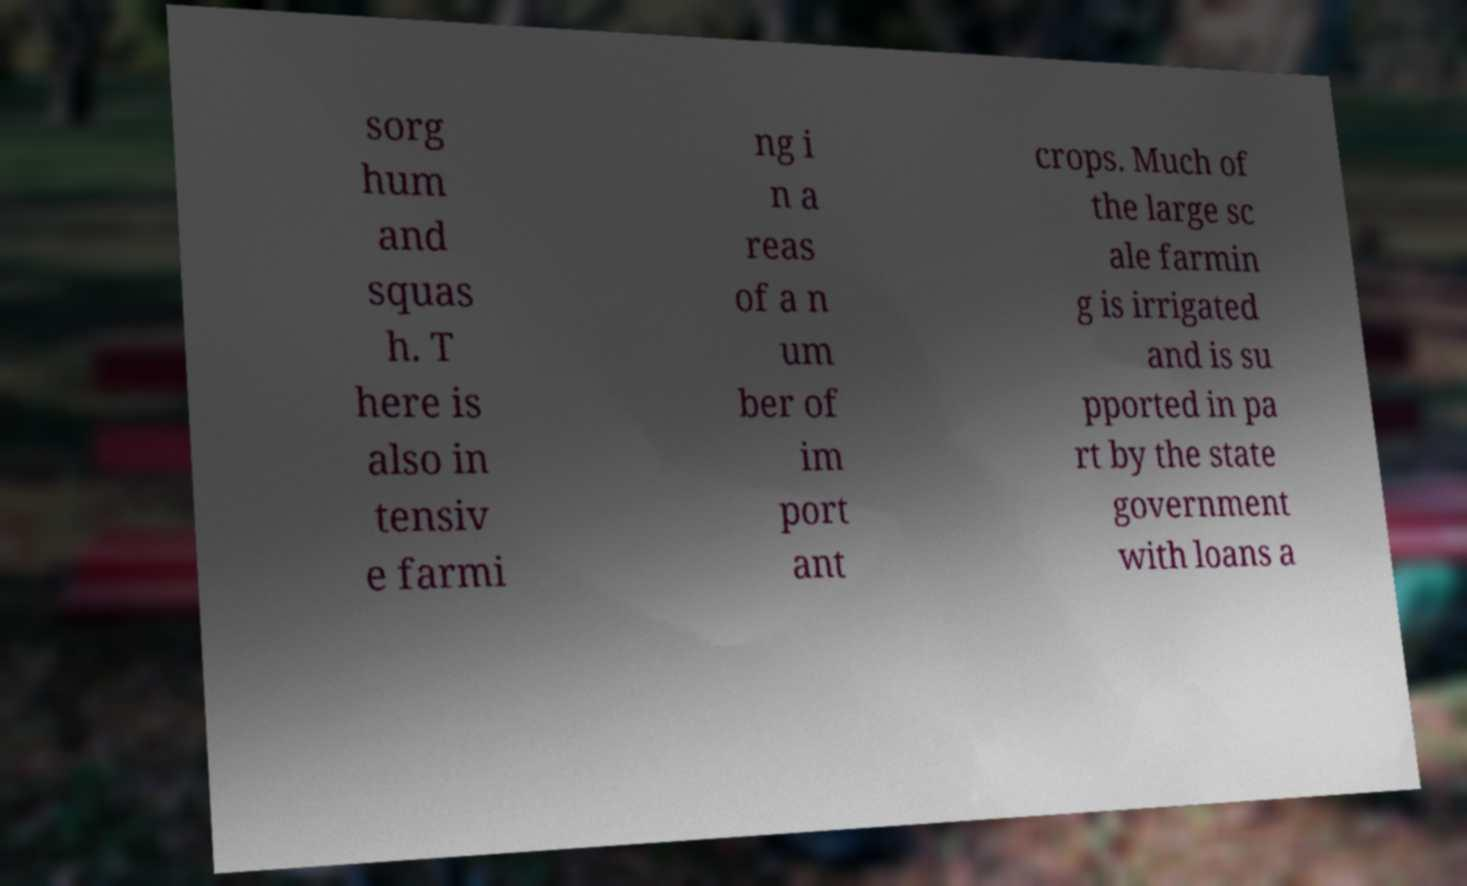Could you extract and type out the text from this image? sorg hum and squas h. T here is also in tensiv e farmi ng i n a reas of a n um ber of im port ant crops. Much of the large sc ale farmin g is irrigated and is su pported in pa rt by the state government with loans a 